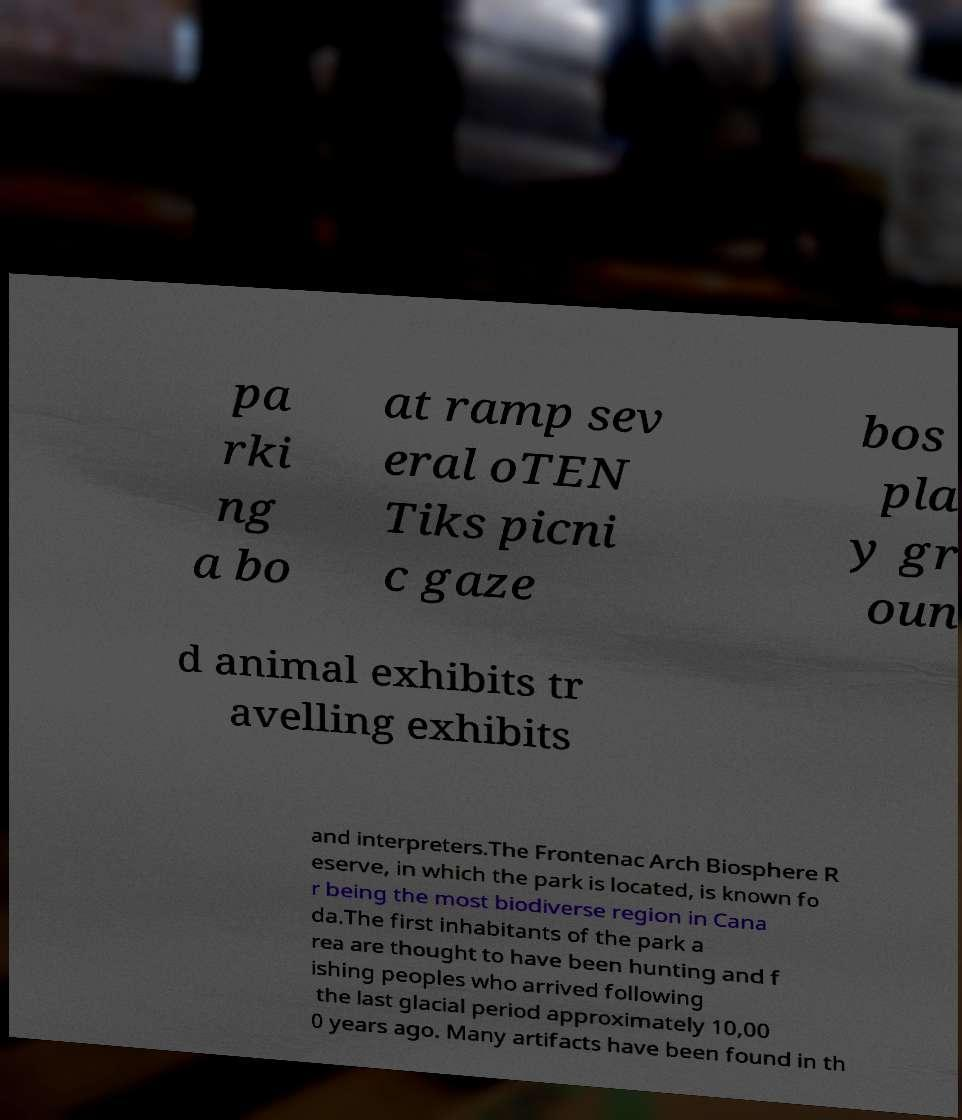Please read and relay the text visible in this image. What does it say? pa rki ng a bo at ramp sev eral oTEN Tiks picni c gaze bos pla y gr oun d animal exhibits tr avelling exhibits and interpreters.The Frontenac Arch Biosphere R eserve, in which the park is located, is known fo r being the most biodiverse region in Cana da.The first inhabitants of the park a rea are thought to have been hunting and f ishing peoples who arrived following the last glacial period approximately 10,00 0 years ago. Many artifacts have been found in th 